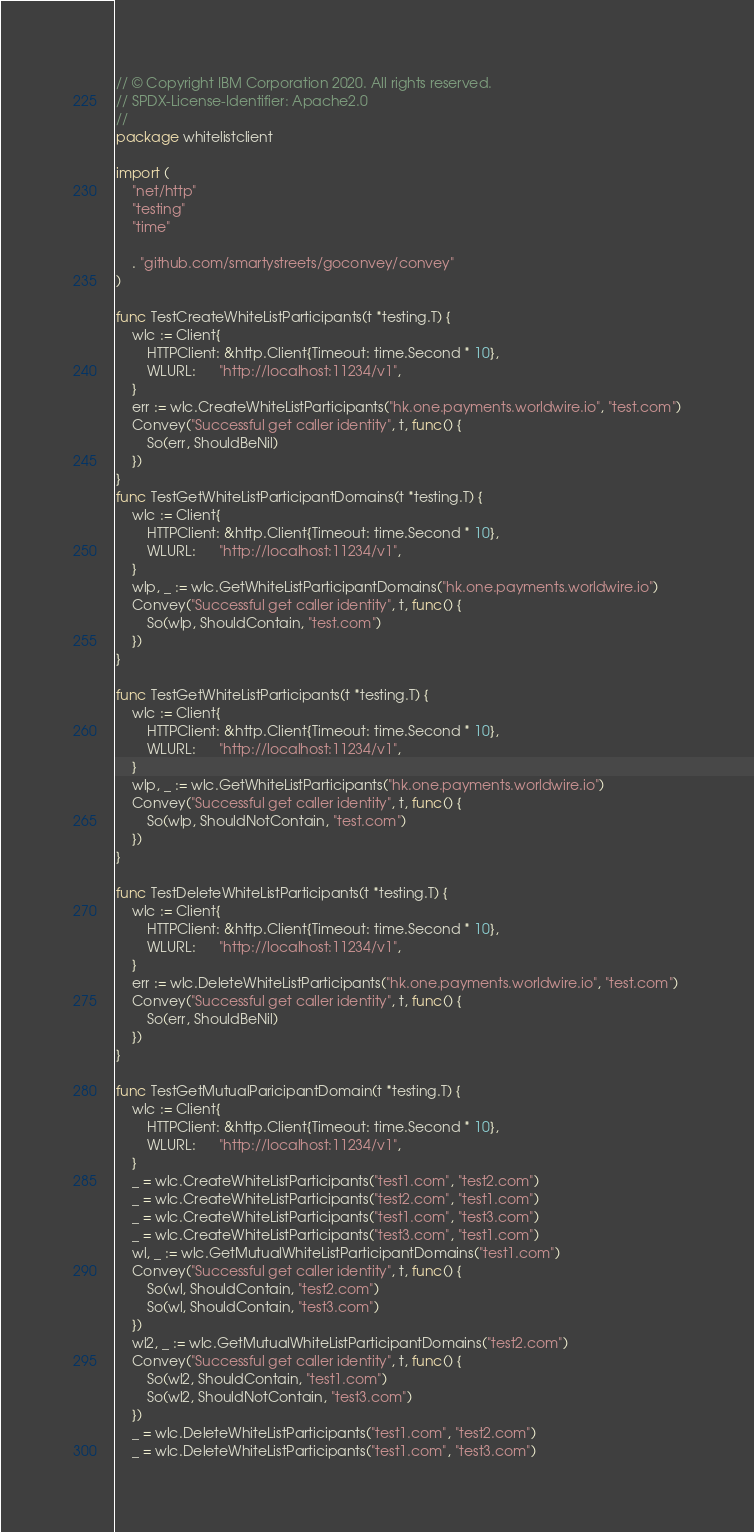<code> <loc_0><loc_0><loc_500><loc_500><_Go_>// © Copyright IBM Corporation 2020. All rights reserved.
// SPDX-License-Identifier: Apache2.0
// 
package whitelistclient

import (
	"net/http"
	"testing"
	"time"

	. "github.com/smartystreets/goconvey/convey"
)

func TestCreateWhiteListParticipants(t *testing.T) {
	wlc := Client{
		HTTPClient: &http.Client{Timeout: time.Second * 10},
		WLURL:      "http://localhost:11234/v1",
	}
	err := wlc.CreateWhiteListParticipants("hk.one.payments.worldwire.io", "test.com")
	Convey("Successful get caller identity", t, func() {
		So(err, ShouldBeNil)
	})
}
func TestGetWhiteListParticipantDomains(t *testing.T) {
	wlc := Client{
		HTTPClient: &http.Client{Timeout: time.Second * 10},
		WLURL:      "http://localhost:11234/v1",
	}
	wlp, _ := wlc.GetWhiteListParticipantDomains("hk.one.payments.worldwire.io")
	Convey("Successful get caller identity", t, func() {
		So(wlp, ShouldContain, "test.com")
	})
}

func TestGetWhiteListParticipants(t *testing.T) {
	wlc := Client{
		HTTPClient: &http.Client{Timeout: time.Second * 10},
		WLURL:      "http://localhost:11234/v1",
	}
	wlp, _ := wlc.GetWhiteListParticipants("hk.one.payments.worldwire.io")
	Convey("Successful get caller identity", t, func() {
		So(wlp, ShouldNotContain, "test.com")
	})
}

func TestDeleteWhiteListParticipants(t *testing.T) {
	wlc := Client{
		HTTPClient: &http.Client{Timeout: time.Second * 10},
		WLURL:      "http://localhost:11234/v1",
	}
	err := wlc.DeleteWhiteListParticipants("hk.one.payments.worldwire.io", "test.com")
	Convey("Successful get caller identity", t, func() {
		So(err, ShouldBeNil)
	})
}

func TestGetMutualParicipantDomain(t *testing.T) {
	wlc := Client{
		HTTPClient: &http.Client{Timeout: time.Second * 10},
		WLURL:      "http://localhost:11234/v1",
	}
	_ = wlc.CreateWhiteListParticipants("test1.com", "test2.com")
	_ = wlc.CreateWhiteListParticipants("test2.com", "test1.com")
	_ = wlc.CreateWhiteListParticipants("test1.com", "test3.com")
	_ = wlc.CreateWhiteListParticipants("test3.com", "test1.com")
	wl, _ := wlc.GetMutualWhiteListParticipantDomains("test1.com")
	Convey("Successful get caller identity", t, func() {
		So(wl, ShouldContain, "test2.com")
		So(wl, ShouldContain, "test3.com")
	})
	wl2, _ := wlc.GetMutualWhiteListParticipantDomains("test2.com")
	Convey("Successful get caller identity", t, func() {
		So(wl2, ShouldContain, "test1.com")
		So(wl2, ShouldNotContain, "test3.com")
	})
	_ = wlc.DeleteWhiteListParticipants("test1.com", "test2.com")
	_ = wlc.DeleteWhiteListParticipants("test1.com", "test3.com")</code> 